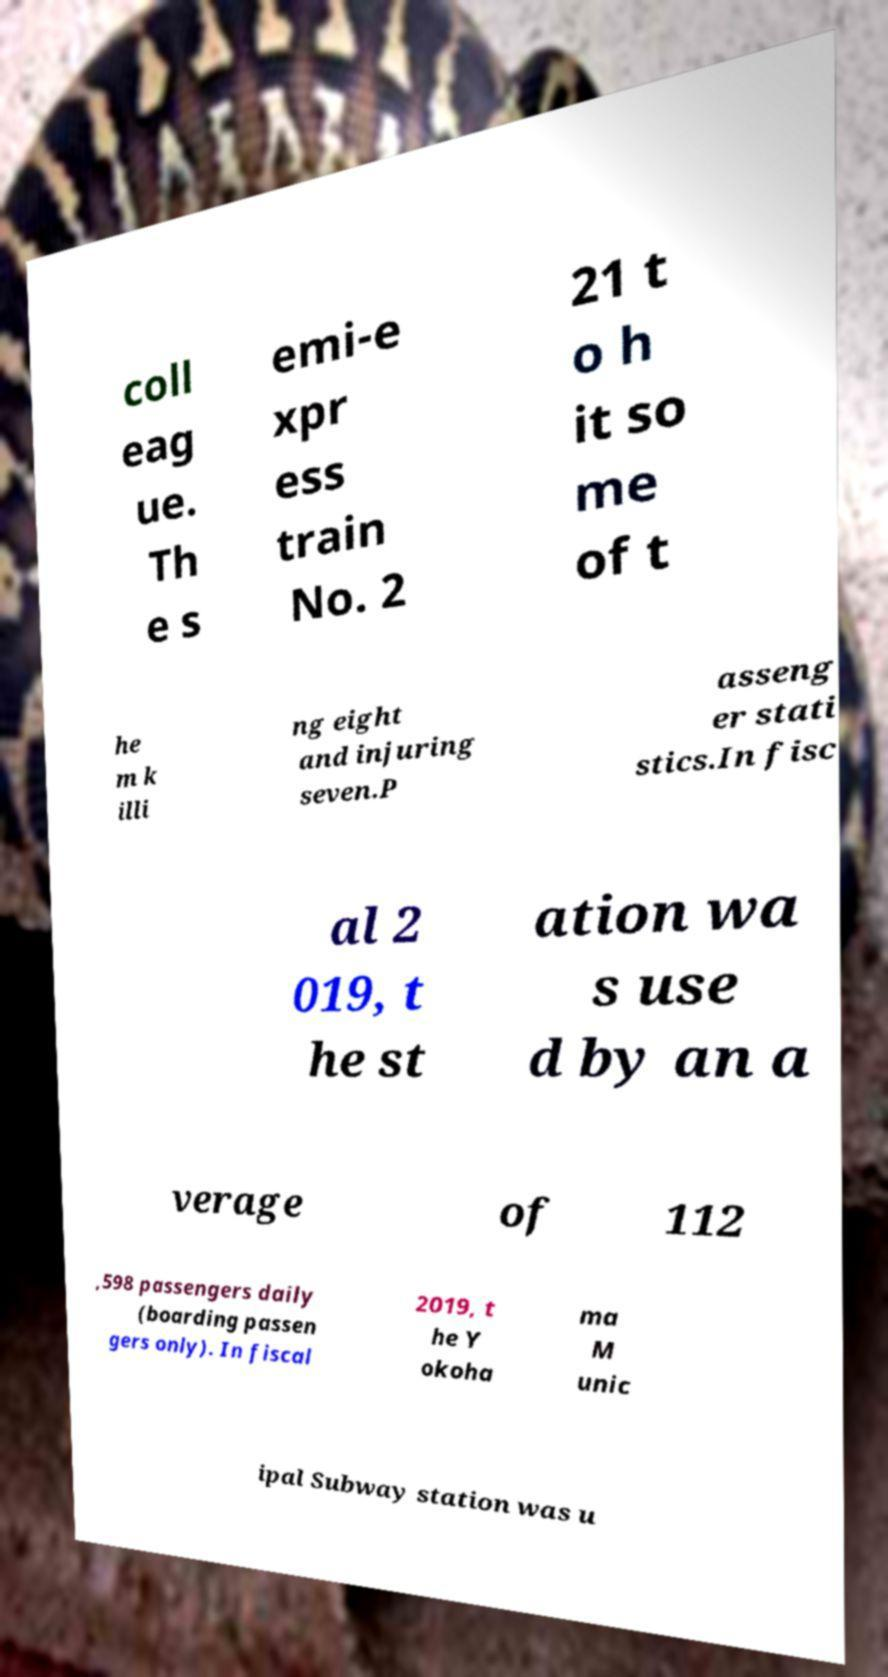Please identify and transcribe the text found in this image. coll eag ue. Th e s emi-e xpr ess train No. 2 21 t o h it so me of t he m k illi ng eight and injuring seven.P asseng er stati stics.In fisc al 2 019, t he st ation wa s use d by an a verage of 112 ,598 passengers daily (boarding passen gers only). In fiscal 2019, t he Y okoha ma M unic ipal Subway station was u 